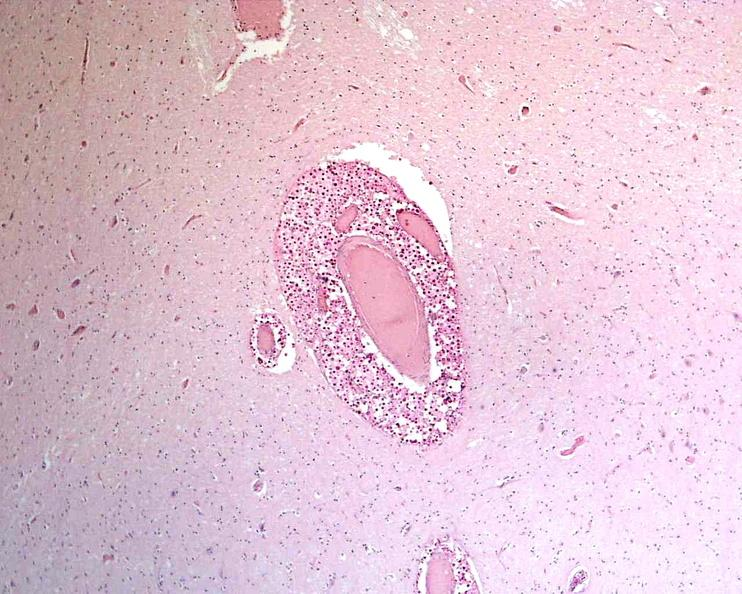what stain?
Answer the question using a single word or phrase. Mucicarmine 